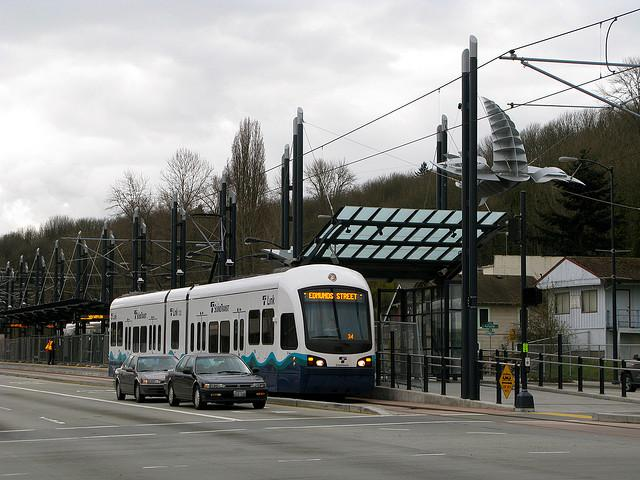What are white lines on road called? crosswalk 